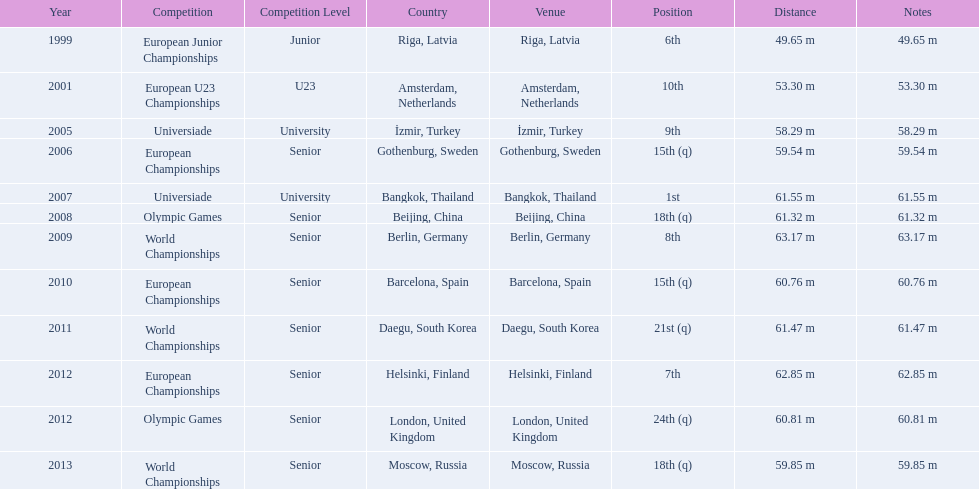What european junior championships? 6th. What waseuropean junior championships best result? 63.17 m. 